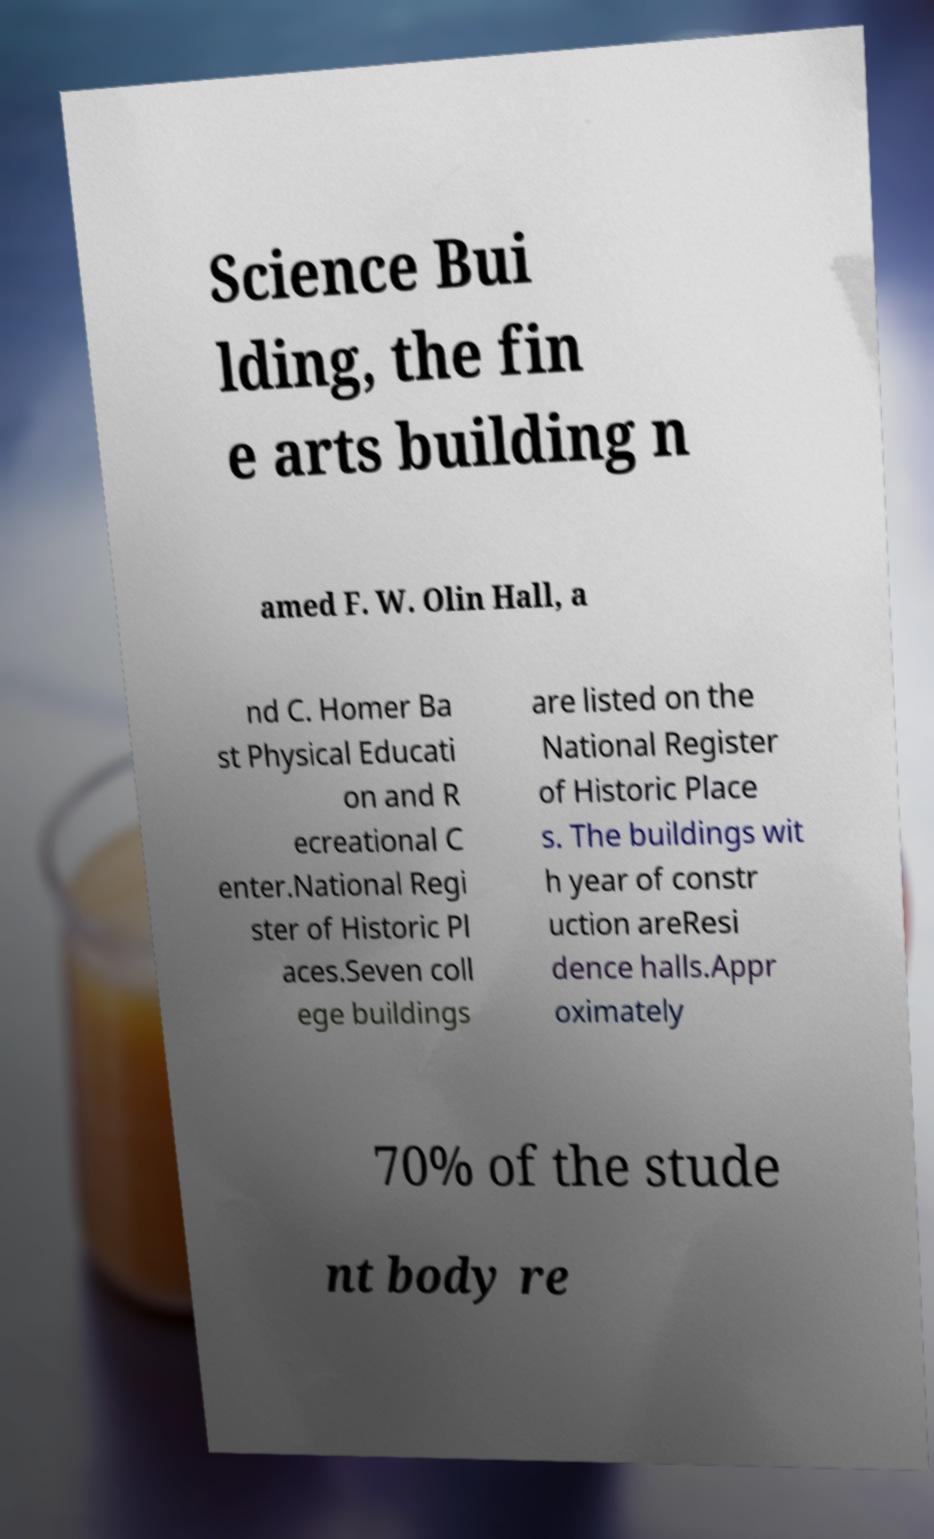Please read and relay the text visible in this image. What does it say? Science Bui lding, the fin e arts building n amed F. W. Olin Hall, a nd C. Homer Ba st Physical Educati on and R ecreational C enter.National Regi ster of Historic Pl aces.Seven coll ege buildings are listed on the National Register of Historic Place s. The buildings wit h year of constr uction areResi dence halls.Appr oximately 70% of the stude nt body re 